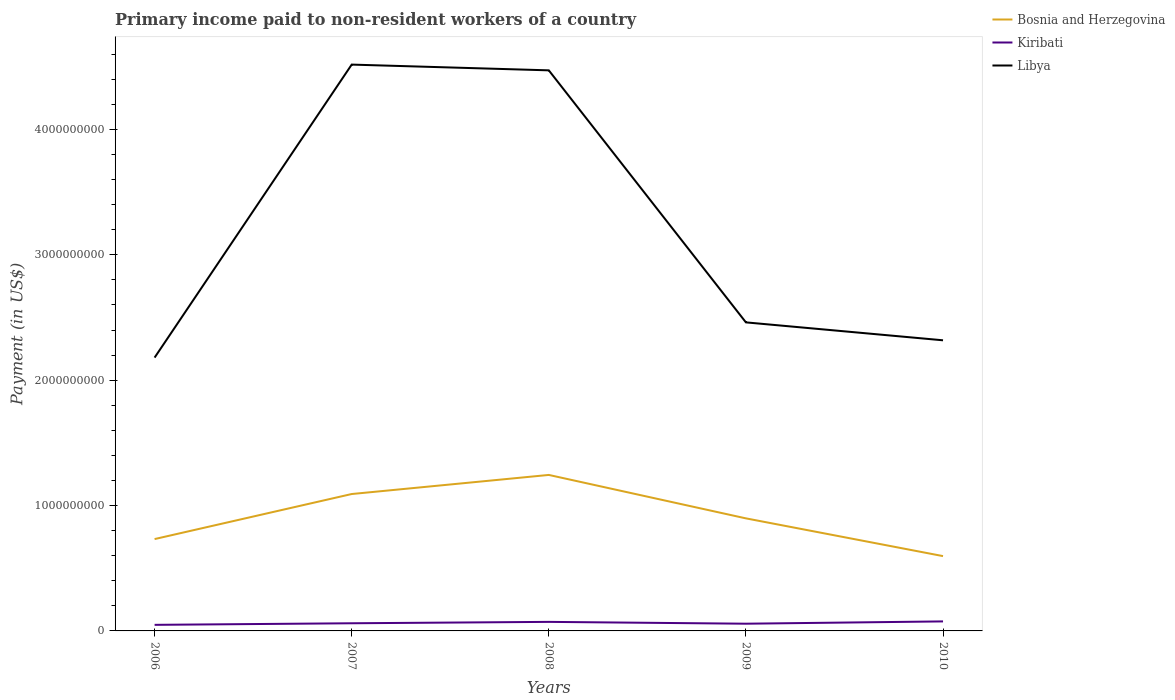How many different coloured lines are there?
Provide a succinct answer. 3. Does the line corresponding to Kiribati intersect with the line corresponding to Libya?
Your response must be concise. No. Is the number of lines equal to the number of legend labels?
Keep it short and to the point. Yes. Across all years, what is the maximum amount paid to workers in Bosnia and Herzegovina?
Make the answer very short. 5.97e+08. In which year was the amount paid to workers in Libya maximum?
Ensure brevity in your answer.  2006. What is the total amount paid to workers in Libya in the graph?
Ensure brevity in your answer.  -2.34e+09. What is the difference between the highest and the second highest amount paid to workers in Libya?
Make the answer very short. 2.34e+09. Are the values on the major ticks of Y-axis written in scientific E-notation?
Your answer should be compact. No. Does the graph contain grids?
Keep it short and to the point. No. Where does the legend appear in the graph?
Give a very brief answer. Top right. How many legend labels are there?
Make the answer very short. 3. How are the legend labels stacked?
Your answer should be compact. Vertical. What is the title of the graph?
Offer a terse response. Primary income paid to non-resident workers of a country. Does "Poland" appear as one of the legend labels in the graph?
Ensure brevity in your answer.  No. What is the label or title of the Y-axis?
Keep it short and to the point. Payment (in US$). What is the Payment (in US$) of Bosnia and Herzegovina in 2006?
Your response must be concise. 7.33e+08. What is the Payment (in US$) in Kiribati in 2006?
Your response must be concise. 4.85e+07. What is the Payment (in US$) of Libya in 2006?
Make the answer very short. 2.18e+09. What is the Payment (in US$) of Bosnia and Herzegovina in 2007?
Your answer should be compact. 1.09e+09. What is the Payment (in US$) in Kiribati in 2007?
Ensure brevity in your answer.  6.10e+07. What is the Payment (in US$) of Libya in 2007?
Make the answer very short. 4.52e+09. What is the Payment (in US$) of Bosnia and Herzegovina in 2008?
Offer a very short reply. 1.24e+09. What is the Payment (in US$) in Kiribati in 2008?
Provide a succinct answer. 7.21e+07. What is the Payment (in US$) in Libya in 2008?
Your answer should be very brief. 4.47e+09. What is the Payment (in US$) of Bosnia and Herzegovina in 2009?
Make the answer very short. 8.98e+08. What is the Payment (in US$) of Kiribati in 2009?
Your answer should be very brief. 5.76e+07. What is the Payment (in US$) of Libya in 2009?
Keep it short and to the point. 2.46e+09. What is the Payment (in US$) of Bosnia and Herzegovina in 2010?
Provide a succinct answer. 5.97e+08. What is the Payment (in US$) in Kiribati in 2010?
Provide a short and direct response. 7.58e+07. What is the Payment (in US$) of Libya in 2010?
Offer a very short reply. 2.32e+09. Across all years, what is the maximum Payment (in US$) of Bosnia and Herzegovina?
Ensure brevity in your answer.  1.24e+09. Across all years, what is the maximum Payment (in US$) in Kiribati?
Ensure brevity in your answer.  7.58e+07. Across all years, what is the maximum Payment (in US$) of Libya?
Offer a very short reply. 4.52e+09. Across all years, what is the minimum Payment (in US$) in Bosnia and Herzegovina?
Your answer should be compact. 5.97e+08. Across all years, what is the minimum Payment (in US$) in Kiribati?
Your answer should be very brief. 4.85e+07. Across all years, what is the minimum Payment (in US$) of Libya?
Your answer should be compact. 2.18e+09. What is the total Payment (in US$) in Bosnia and Herzegovina in the graph?
Your answer should be very brief. 4.56e+09. What is the total Payment (in US$) in Kiribati in the graph?
Your answer should be very brief. 3.15e+08. What is the total Payment (in US$) in Libya in the graph?
Make the answer very short. 1.59e+1. What is the difference between the Payment (in US$) of Bosnia and Herzegovina in 2006 and that in 2007?
Your response must be concise. -3.59e+08. What is the difference between the Payment (in US$) in Kiribati in 2006 and that in 2007?
Make the answer very short. -1.26e+07. What is the difference between the Payment (in US$) of Libya in 2006 and that in 2007?
Provide a succinct answer. -2.34e+09. What is the difference between the Payment (in US$) in Bosnia and Herzegovina in 2006 and that in 2008?
Offer a terse response. -5.12e+08. What is the difference between the Payment (in US$) in Kiribati in 2006 and that in 2008?
Provide a short and direct response. -2.37e+07. What is the difference between the Payment (in US$) in Libya in 2006 and that in 2008?
Make the answer very short. -2.29e+09. What is the difference between the Payment (in US$) of Bosnia and Herzegovina in 2006 and that in 2009?
Your answer should be compact. -1.65e+08. What is the difference between the Payment (in US$) in Kiribati in 2006 and that in 2009?
Make the answer very short. -9.12e+06. What is the difference between the Payment (in US$) in Libya in 2006 and that in 2009?
Give a very brief answer. -2.81e+08. What is the difference between the Payment (in US$) of Bosnia and Herzegovina in 2006 and that in 2010?
Your response must be concise. 1.36e+08. What is the difference between the Payment (in US$) of Kiribati in 2006 and that in 2010?
Ensure brevity in your answer.  -2.74e+07. What is the difference between the Payment (in US$) of Libya in 2006 and that in 2010?
Your answer should be compact. -1.38e+08. What is the difference between the Payment (in US$) in Bosnia and Herzegovina in 2007 and that in 2008?
Your answer should be compact. -1.52e+08. What is the difference between the Payment (in US$) in Kiribati in 2007 and that in 2008?
Your response must be concise. -1.11e+07. What is the difference between the Payment (in US$) of Libya in 2007 and that in 2008?
Offer a terse response. 4.59e+07. What is the difference between the Payment (in US$) of Bosnia and Herzegovina in 2007 and that in 2009?
Keep it short and to the point. 1.94e+08. What is the difference between the Payment (in US$) of Kiribati in 2007 and that in 2009?
Ensure brevity in your answer.  3.45e+06. What is the difference between the Payment (in US$) of Libya in 2007 and that in 2009?
Ensure brevity in your answer.  2.06e+09. What is the difference between the Payment (in US$) in Bosnia and Herzegovina in 2007 and that in 2010?
Give a very brief answer. 4.95e+08. What is the difference between the Payment (in US$) in Kiribati in 2007 and that in 2010?
Offer a very short reply. -1.48e+07. What is the difference between the Payment (in US$) of Libya in 2007 and that in 2010?
Offer a very short reply. 2.20e+09. What is the difference between the Payment (in US$) in Bosnia and Herzegovina in 2008 and that in 2009?
Provide a succinct answer. 3.46e+08. What is the difference between the Payment (in US$) of Kiribati in 2008 and that in 2009?
Make the answer very short. 1.46e+07. What is the difference between the Payment (in US$) of Libya in 2008 and that in 2009?
Your response must be concise. 2.01e+09. What is the difference between the Payment (in US$) in Bosnia and Herzegovina in 2008 and that in 2010?
Keep it short and to the point. 6.47e+08. What is the difference between the Payment (in US$) in Kiribati in 2008 and that in 2010?
Provide a succinct answer. -3.69e+06. What is the difference between the Payment (in US$) in Libya in 2008 and that in 2010?
Your response must be concise. 2.15e+09. What is the difference between the Payment (in US$) in Bosnia and Herzegovina in 2009 and that in 2010?
Give a very brief answer. 3.01e+08. What is the difference between the Payment (in US$) in Kiribati in 2009 and that in 2010?
Give a very brief answer. -1.82e+07. What is the difference between the Payment (in US$) of Libya in 2009 and that in 2010?
Your answer should be very brief. 1.43e+08. What is the difference between the Payment (in US$) of Bosnia and Herzegovina in 2006 and the Payment (in US$) of Kiribati in 2007?
Your answer should be compact. 6.72e+08. What is the difference between the Payment (in US$) of Bosnia and Herzegovina in 2006 and the Payment (in US$) of Libya in 2007?
Provide a short and direct response. -3.78e+09. What is the difference between the Payment (in US$) of Kiribati in 2006 and the Payment (in US$) of Libya in 2007?
Ensure brevity in your answer.  -4.47e+09. What is the difference between the Payment (in US$) of Bosnia and Herzegovina in 2006 and the Payment (in US$) of Kiribati in 2008?
Offer a very short reply. 6.60e+08. What is the difference between the Payment (in US$) in Bosnia and Herzegovina in 2006 and the Payment (in US$) in Libya in 2008?
Give a very brief answer. -3.74e+09. What is the difference between the Payment (in US$) of Kiribati in 2006 and the Payment (in US$) of Libya in 2008?
Keep it short and to the point. -4.42e+09. What is the difference between the Payment (in US$) of Bosnia and Herzegovina in 2006 and the Payment (in US$) of Kiribati in 2009?
Keep it short and to the point. 6.75e+08. What is the difference between the Payment (in US$) in Bosnia and Herzegovina in 2006 and the Payment (in US$) in Libya in 2009?
Provide a short and direct response. -1.73e+09. What is the difference between the Payment (in US$) in Kiribati in 2006 and the Payment (in US$) in Libya in 2009?
Make the answer very short. -2.41e+09. What is the difference between the Payment (in US$) in Bosnia and Herzegovina in 2006 and the Payment (in US$) in Kiribati in 2010?
Make the answer very short. 6.57e+08. What is the difference between the Payment (in US$) of Bosnia and Herzegovina in 2006 and the Payment (in US$) of Libya in 2010?
Offer a very short reply. -1.59e+09. What is the difference between the Payment (in US$) in Kiribati in 2006 and the Payment (in US$) in Libya in 2010?
Ensure brevity in your answer.  -2.27e+09. What is the difference between the Payment (in US$) in Bosnia and Herzegovina in 2007 and the Payment (in US$) in Kiribati in 2008?
Ensure brevity in your answer.  1.02e+09. What is the difference between the Payment (in US$) in Bosnia and Herzegovina in 2007 and the Payment (in US$) in Libya in 2008?
Offer a very short reply. -3.38e+09. What is the difference between the Payment (in US$) in Kiribati in 2007 and the Payment (in US$) in Libya in 2008?
Your answer should be compact. -4.41e+09. What is the difference between the Payment (in US$) in Bosnia and Herzegovina in 2007 and the Payment (in US$) in Kiribati in 2009?
Your answer should be very brief. 1.03e+09. What is the difference between the Payment (in US$) of Bosnia and Herzegovina in 2007 and the Payment (in US$) of Libya in 2009?
Your answer should be very brief. -1.37e+09. What is the difference between the Payment (in US$) of Kiribati in 2007 and the Payment (in US$) of Libya in 2009?
Your response must be concise. -2.40e+09. What is the difference between the Payment (in US$) in Bosnia and Herzegovina in 2007 and the Payment (in US$) in Kiribati in 2010?
Make the answer very short. 1.02e+09. What is the difference between the Payment (in US$) of Bosnia and Herzegovina in 2007 and the Payment (in US$) of Libya in 2010?
Offer a terse response. -1.23e+09. What is the difference between the Payment (in US$) in Kiribati in 2007 and the Payment (in US$) in Libya in 2010?
Give a very brief answer. -2.26e+09. What is the difference between the Payment (in US$) of Bosnia and Herzegovina in 2008 and the Payment (in US$) of Kiribati in 2009?
Ensure brevity in your answer.  1.19e+09. What is the difference between the Payment (in US$) of Bosnia and Herzegovina in 2008 and the Payment (in US$) of Libya in 2009?
Offer a terse response. -1.22e+09. What is the difference between the Payment (in US$) in Kiribati in 2008 and the Payment (in US$) in Libya in 2009?
Your response must be concise. -2.39e+09. What is the difference between the Payment (in US$) in Bosnia and Herzegovina in 2008 and the Payment (in US$) in Kiribati in 2010?
Provide a succinct answer. 1.17e+09. What is the difference between the Payment (in US$) in Bosnia and Herzegovina in 2008 and the Payment (in US$) in Libya in 2010?
Make the answer very short. -1.07e+09. What is the difference between the Payment (in US$) in Kiribati in 2008 and the Payment (in US$) in Libya in 2010?
Make the answer very short. -2.25e+09. What is the difference between the Payment (in US$) in Bosnia and Herzegovina in 2009 and the Payment (in US$) in Kiribati in 2010?
Provide a succinct answer. 8.22e+08. What is the difference between the Payment (in US$) in Bosnia and Herzegovina in 2009 and the Payment (in US$) in Libya in 2010?
Offer a terse response. -1.42e+09. What is the difference between the Payment (in US$) of Kiribati in 2009 and the Payment (in US$) of Libya in 2010?
Your answer should be very brief. -2.26e+09. What is the average Payment (in US$) in Bosnia and Herzegovina per year?
Ensure brevity in your answer.  9.13e+08. What is the average Payment (in US$) of Kiribati per year?
Your answer should be compact. 6.30e+07. What is the average Payment (in US$) in Libya per year?
Make the answer very short. 3.19e+09. In the year 2006, what is the difference between the Payment (in US$) in Bosnia and Herzegovina and Payment (in US$) in Kiribati?
Keep it short and to the point. 6.84e+08. In the year 2006, what is the difference between the Payment (in US$) in Bosnia and Herzegovina and Payment (in US$) in Libya?
Provide a short and direct response. -1.45e+09. In the year 2006, what is the difference between the Payment (in US$) of Kiribati and Payment (in US$) of Libya?
Provide a short and direct response. -2.13e+09. In the year 2007, what is the difference between the Payment (in US$) of Bosnia and Herzegovina and Payment (in US$) of Kiribati?
Give a very brief answer. 1.03e+09. In the year 2007, what is the difference between the Payment (in US$) of Bosnia and Herzegovina and Payment (in US$) of Libya?
Your answer should be compact. -3.43e+09. In the year 2007, what is the difference between the Payment (in US$) of Kiribati and Payment (in US$) of Libya?
Provide a short and direct response. -4.46e+09. In the year 2008, what is the difference between the Payment (in US$) of Bosnia and Herzegovina and Payment (in US$) of Kiribati?
Give a very brief answer. 1.17e+09. In the year 2008, what is the difference between the Payment (in US$) of Bosnia and Herzegovina and Payment (in US$) of Libya?
Your answer should be compact. -3.23e+09. In the year 2008, what is the difference between the Payment (in US$) of Kiribati and Payment (in US$) of Libya?
Offer a terse response. -4.40e+09. In the year 2009, what is the difference between the Payment (in US$) in Bosnia and Herzegovina and Payment (in US$) in Kiribati?
Ensure brevity in your answer.  8.40e+08. In the year 2009, what is the difference between the Payment (in US$) of Bosnia and Herzegovina and Payment (in US$) of Libya?
Your response must be concise. -1.56e+09. In the year 2009, what is the difference between the Payment (in US$) of Kiribati and Payment (in US$) of Libya?
Your answer should be very brief. -2.40e+09. In the year 2010, what is the difference between the Payment (in US$) of Bosnia and Herzegovina and Payment (in US$) of Kiribati?
Provide a succinct answer. 5.21e+08. In the year 2010, what is the difference between the Payment (in US$) in Bosnia and Herzegovina and Payment (in US$) in Libya?
Provide a succinct answer. -1.72e+09. In the year 2010, what is the difference between the Payment (in US$) in Kiribati and Payment (in US$) in Libya?
Offer a terse response. -2.24e+09. What is the ratio of the Payment (in US$) in Bosnia and Herzegovina in 2006 to that in 2007?
Your response must be concise. 0.67. What is the ratio of the Payment (in US$) in Kiribati in 2006 to that in 2007?
Make the answer very short. 0.79. What is the ratio of the Payment (in US$) in Libya in 2006 to that in 2007?
Provide a short and direct response. 0.48. What is the ratio of the Payment (in US$) in Bosnia and Herzegovina in 2006 to that in 2008?
Offer a very short reply. 0.59. What is the ratio of the Payment (in US$) in Kiribati in 2006 to that in 2008?
Your answer should be compact. 0.67. What is the ratio of the Payment (in US$) of Libya in 2006 to that in 2008?
Your answer should be compact. 0.49. What is the ratio of the Payment (in US$) of Bosnia and Herzegovina in 2006 to that in 2009?
Provide a short and direct response. 0.82. What is the ratio of the Payment (in US$) of Kiribati in 2006 to that in 2009?
Provide a succinct answer. 0.84. What is the ratio of the Payment (in US$) of Libya in 2006 to that in 2009?
Your answer should be compact. 0.89. What is the ratio of the Payment (in US$) of Bosnia and Herzegovina in 2006 to that in 2010?
Provide a succinct answer. 1.23. What is the ratio of the Payment (in US$) in Kiribati in 2006 to that in 2010?
Your answer should be very brief. 0.64. What is the ratio of the Payment (in US$) of Libya in 2006 to that in 2010?
Offer a very short reply. 0.94. What is the ratio of the Payment (in US$) of Bosnia and Herzegovina in 2007 to that in 2008?
Offer a very short reply. 0.88. What is the ratio of the Payment (in US$) of Kiribati in 2007 to that in 2008?
Your answer should be compact. 0.85. What is the ratio of the Payment (in US$) in Libya in 2007 to that in 2008?
Your answer should be compact. 1.01. What is the ratio of the Payment (in US$) of Bosnia and Herzegovina in 2007 to that in 2009?
Keep it short and to the point. 1.22. What is the ratio of the Payment (in US$) of Kiribati in 2007 to that in 2009?
Ensure brevity in your answer.  1.06. What is the ratio of the Payment (in US$) of Libya in 2007 to that in 2009?
Ensure brevity in your answer.  1.84. What is the ratio of the Payment (in US$) of Bosnia and Herzegovina in 2007 to that in 2010?
Keep it short and to the point. 1.83. What is the ratio of the Payment (in US$) of Kiribati in 2007 to that in 2010?
Your response must be concise. 0.81. What is the ratio of the Payment (in US$) of Libya in 2007 to that in 2010?
Provide a short and direct response. 1.95. What is the ratio of the Payment (in US$) of Bosnia and Herzegovina in 2008 to that in 2009?
Make the answer very short. 1.39. What is the ratio of the Payment (in US$) in Kiribati in 2008 to that in 2009?
Your answer should be very brief. 1.25. What is the ratio of the Payment (in US$) in Libya in 2008 to that in 2009?
Ensure brevity in your answer.  1.82. What is the ratio of the Payment (in US$) of Bosnia and Herzegovina in 2008 to that in 2010?
Your answer should be very brief. 2.09. What is the ratio of the Payment (in US$) of Kiribati in 2008 to that in 2010?
Provide a succinct answer. 0.95. What is the ratio of the Payment (in US$) in Libya in 2008 to that in 2010?
Your answer should be compact. 1.93. What is the ratio of the Payment (in US$) of Bosnia and Herzegovina in 2009 to that in 2010?
Offer a very short reply. 1.5. What is the ratio of the Payment (in US$) in Kiribati in 2009 to that in 2010?
Keep it short and to the point. 0.76. What is the ratio of the Payment (in US$) of Libya in 2009 to that in 2010?
Provide a succinct answer. 1.06. What is the difference between the highest and the second highest Payment (in US$) in Bosnia and Herzegovina?
Make the answer very short. 1.52e+08. What is the difference between the highest and the second highest Payment (in US$) in Kiribati?
Provide a short and direct response. 3.69e+06. What is the difference between the highest and the second highest Payment (in US$) of Libya?
Your answer should be compact. 4.59e+07. What is the difference between the highest and the lowest Payment (in US$) in Bosnia and Herzegovina?
Offer a terse response. 6.47e+08. What is the difference between the highest and the lowest Payment (in US$) of Kiribati?
Provide a succinct answer. 2.74e+07. What is the difference between the highest and the lowest Payment (in US$) in Libya?
Your response must be concise. 2.34e+09. 